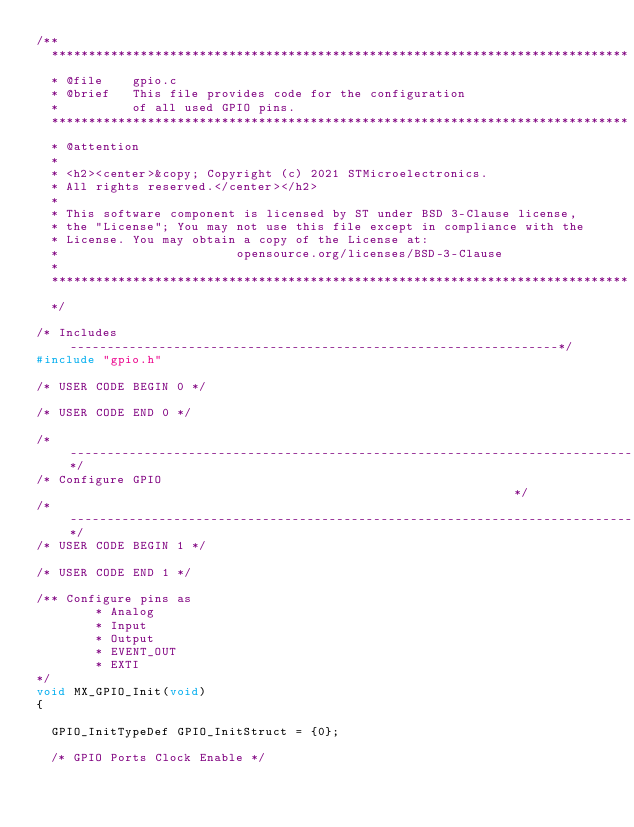<code> <loc_0><loc_0><loc_500><loc_500><_C_>/**
  ******************************************************************************
  * @file    gpio.c
  * @brief   This file provides code for the configuration
  *          of all used GPIO pins.
  ******************************************************************************
  * @attention
  *
  * <h2><center>&copy; Copyright (c) 2021 STMicroelectronics.
  * All rights reserved.</center></h2>
  *
  * This software component is licensed by ST under BSD 3-Clause license,
  * the "License"; You may not use this file except in compliance with the
  * License. You may obtain a copy of the License at:
  *                        opensource.org/licenses/BSD-3-Clause
  *
  ******************************************************************************
  */

/* Includes ------------------------------------------------------------------*/
#include "gpio.h"

/* USER CODE BEGIN 0 */

/* USER CODE END 0 */

/*----------------------------------------------------------------------------*/
/* Configure GPIO                                                             */
/*----------------------------------------------------------------------------*/
/* USER CODE BEGIN 1 */

/* USER CODE END 1 */

/** Configure pins as
        * Analog
        * Input
        * Output
        * EVENT_OUT
        * EXTI
*/
void MX_GPIO_Init(void)
{

  GPIO_InitTypeDef GPIO_InitStruct = {0};

  /* GPIO Ports Clock Enable */</code> 